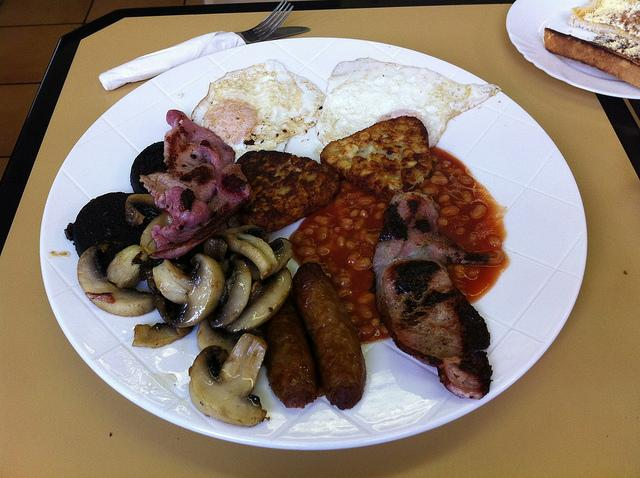How many eggs are served beside the hash browns in this breakfast plate? two 